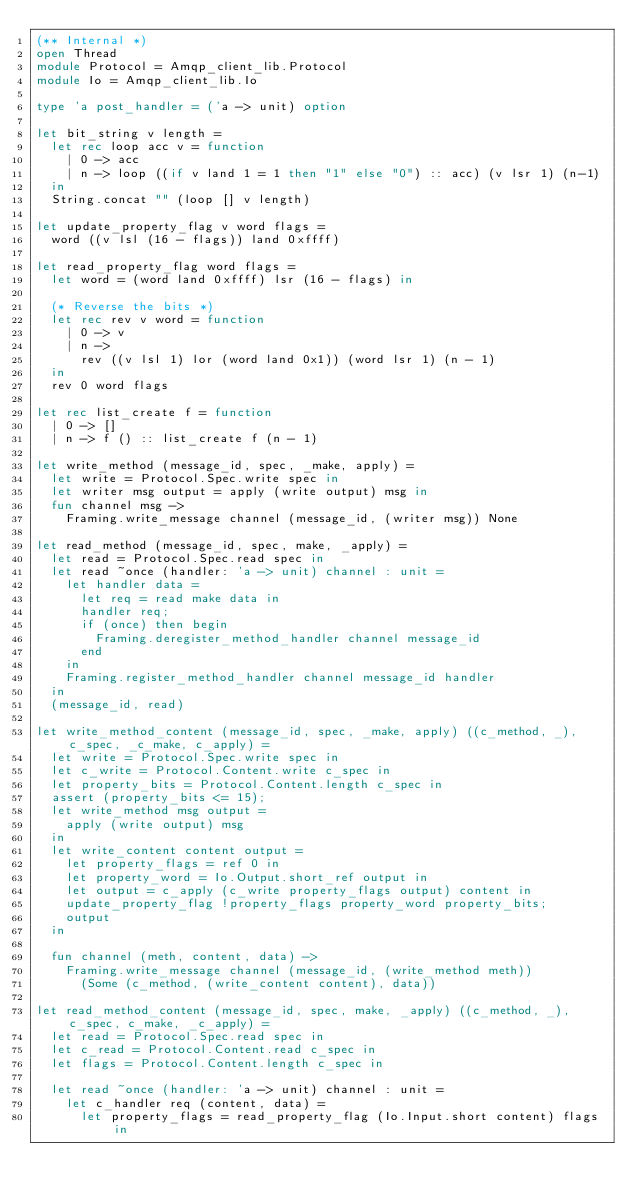Convert code to text. <code><loc_0><loc_0><loc_500><loc_500><_OCaml_>(** Internal *)
open Thread
module Protocol = Amqp_client_lib.Protocol
module Io = Amqp_client_lib.Io

type 'a post_handler = ('a -> unit) option

let bit_string v length =
  let rec loop acc v = function
    | 0 -> acc
    | n -> loop ((if v land 1 = 1 then "1" else "0") :: acc) (v lsr 1) (n-1)
  in
  String.concat "" (loop [] v length)

let update_property_flag v word flags =
  word ((v lsl (16 - flags)) land 0xffff)

let read_property_flag word flags =
  let word = (word land 0xffff) lsr (16 - flags) in

  (* Reverse the bits *)
  let rec rev v word = function
    | 0 -> v
    | n ->
      rev ((v lsl 1) lor (word land 0x1)) (word lsr 1) (n - 1)
  in
  rev 0 word flags

let rec list_create f = function
  | 0 -> []
  | n -> f () :: list_create f (n - 1)

let write_method (message_id, spec, _make, apply) =
  let write = Protocol.Spec.write spec in
  let writer msg output = apply (write output) msg in
  fun channel msg ->
    Framing.write_message channel (message_id, (writer msg)) None

let read_method (message_id, spec, make, _apply) =
  let read = Protocol.Spec.read spec in
  let read ~once (handler: 'a -> unit) channel : unit =
    let handler data =
      let req = read make data in
      handler req;
      if (once) then begin
        Framing.deregister_method_handler channel message_id
      end
    in
    Framing.register_method_handler channel message_id handler
  in
  (message_id, read)

let write_method_content (message_id, spec, _make, apply) ((c_method, _), c_spec, _c_make, c_apply) =
  let write = Protocol.Spec.write spec in
  let c_write = Protocol.Content.write c_spec in
  let property_bits = Protocol.Content.length c_spec in
  assert (property_bits <= 15);
  let write_method msg output =
    apply (write output) msg
  in
  let write_content content output =
    let property_flags = ref 0 in
    let property_word = Io.Output.short_ref output in
    let output = c_apply (c_write property_flags output) content in
    update_property_flag !property_flags property_word property_bits;
    output
  in

  fun channel (meth, content, data) ->
    Framing.write_message channel (message_id, (write_method meth))
      (Some (c_method, (write_content content), data))

let read_method_content (message_id, spec, make, _apply) ((c_method, _), c_spec, c_make, _c_apply) =
  let read = Protocol.Spec.read spec in
  let c_read = Protocol.Content.read c_spec in
  let flags = Protocol.Content.length c_spec in

  let read ~once (handler: 'a -> unit) channel : unit =
    let c_handler req (content, data) =
      let property_flags = read_property_flag (Io.Input.short content) flags in</code> 